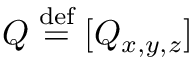<formula> <loc_0><loc_0><loc_500><loc_500>Q \stackrel { d e f } { = } [ Q _ { x , y , z } ]</formula> 